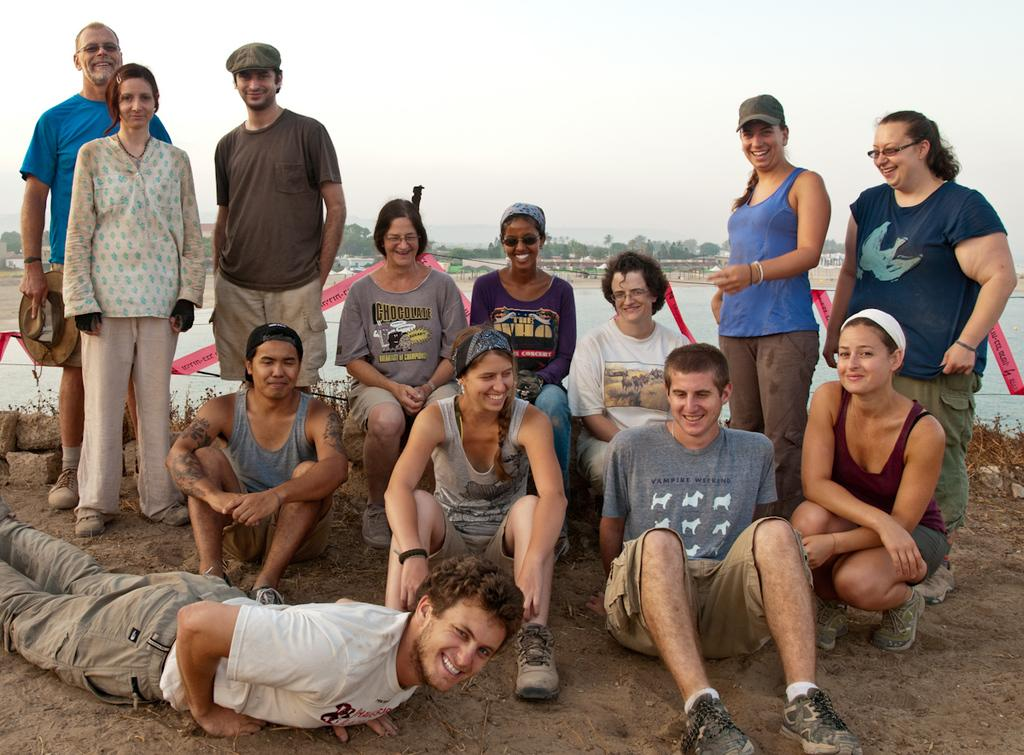How many people are in the image? There is a group of people in the image. What are some of the positions of the people in the image? Some people are standing, some are seated, and a man is lying on the ground. What natural elements can be seen in the image? There are rocks, water, and trees visible in the image. What is the weight of the nose in the image? There is no nose present in the image, so it is not possible to determine its weight. 